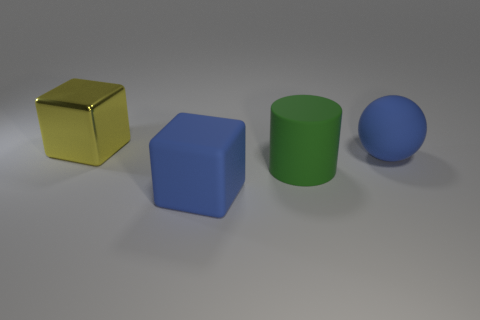Add 3 large cyan shiny cylinders. How many objects exist? 7 Subtract all gray cylinders. How many yellow blocks are left? 1 Subtract all tiny cyan rubber blocks. Subtract all big rubber objects. How many objects are left? 1 Add 1 big blue spheres. How many big blue spheres are left? 2 Add 3 large matte blocks. How many large matte blocks exist? 4 Subtract 0 brown cylinders. How many objects are left? 4 Subtract all balls. How many objects are left? 3 Subtract 1 cylinders. How many cylinders are left? 0 Subtract all purple cubes. Subtract all blue cylinders. How many cubes are left? 2 